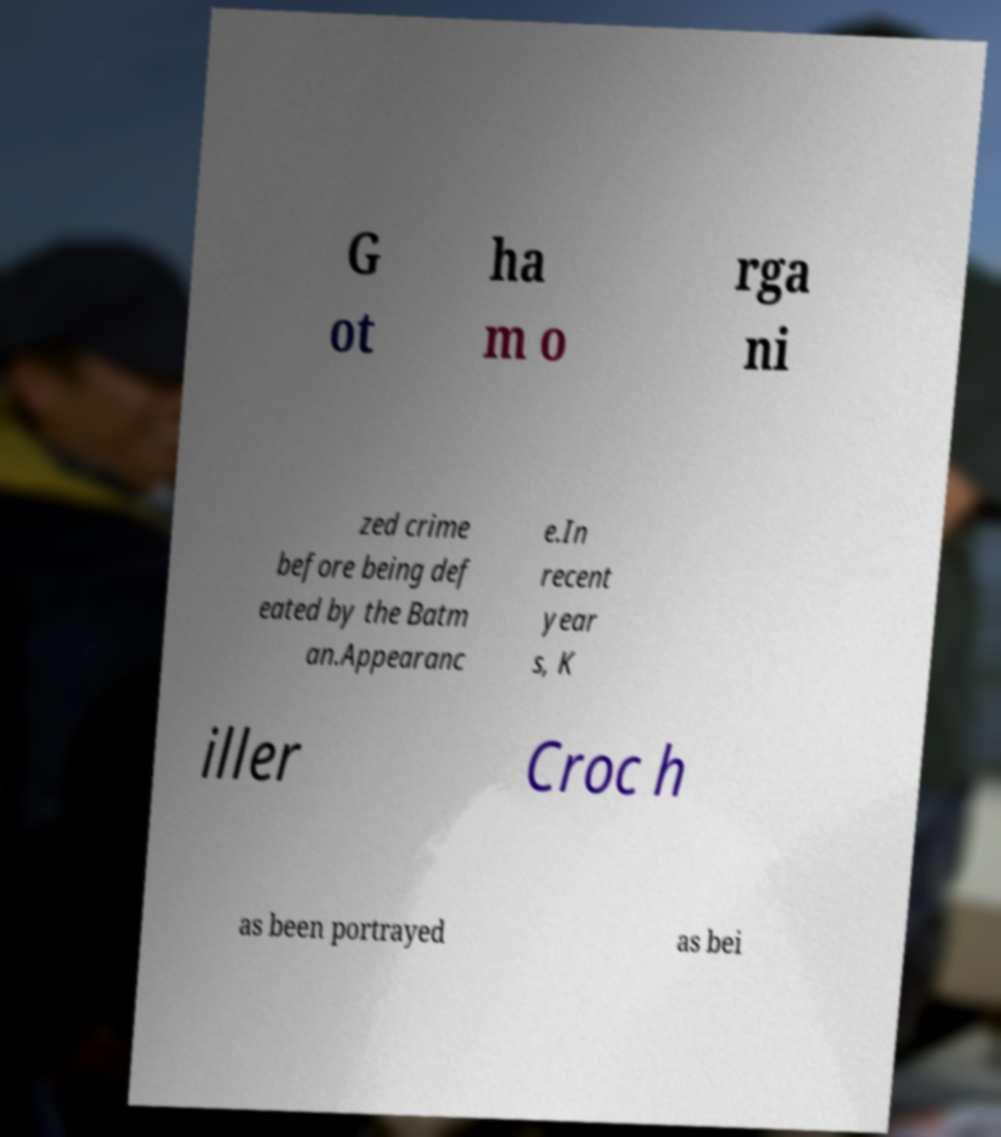Can you read and provide the text displayed in the image?This photo seems to have some interesting text. Can you extract and type it out for me? G ot ha m o rga ni zed crime before being def eated by the Batm an.Appearanc e.In recent year s, K iller Croc h as been portrayed as bei 